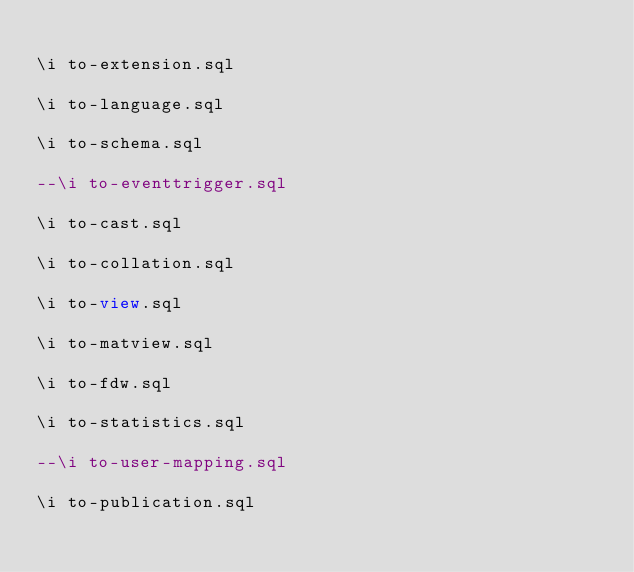Convert code to text. <code><loc_0><loc_0><loc_500><loc_500><_SQL_>
\i to-extension.sql

\i to-language.sql

\i to-schema.sql

--\i to-eventtrigger.sql

\i to-cast.sql

\i to-collation.sql

\i to-view.sql

\i to-matview.sql

\i to-fdw.sql

\i to-statistics.sql

--\i to-user-mapping.sql

\i to-publication.sql
</code> 